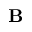<formula> <loc_0><loc_0><loc_500><loc_500>B</formula> 